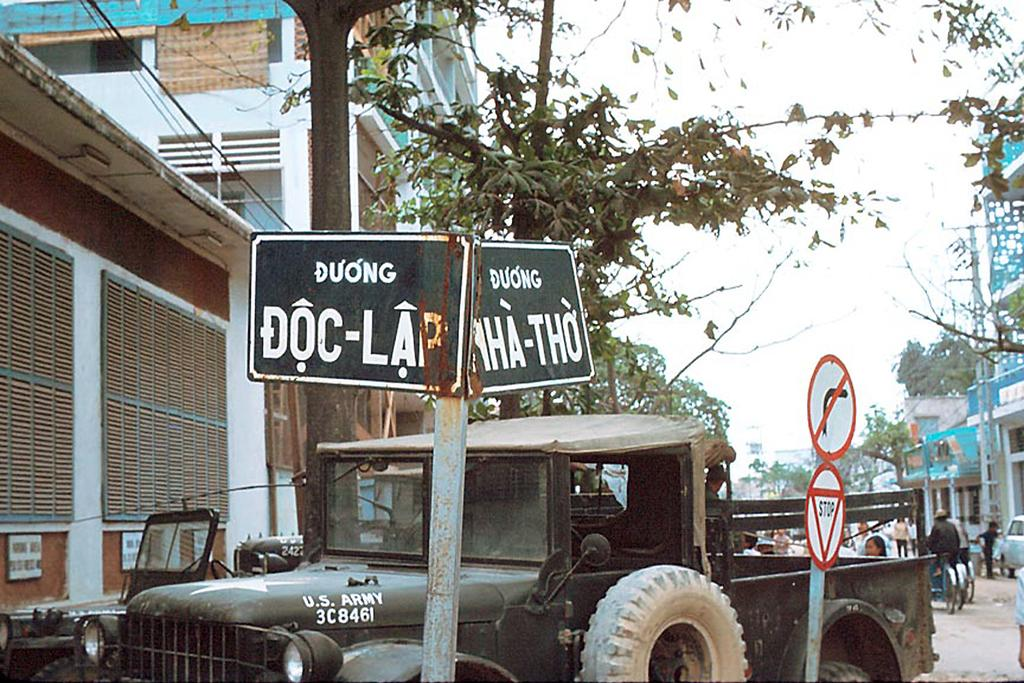What types of objects are on the ground in the image? There are vehicles on the ground in the image. What can be seen on the buildings or structures in the image? Name boards and sign boards are visible in the image. What can be seen in the background of the image? There are buildings, persons, and trees in the background of the image. What type of jewel can be seen hanging from the trees in the image? There are no jewels present in the image; it features vehicles, name boards, sign boards, buildings, persons, and trees. How low are the plants in the image? There are no plants mentioned in the image; it only includes vehicles, name boards, sign boards, buildings, persons, and trees. 